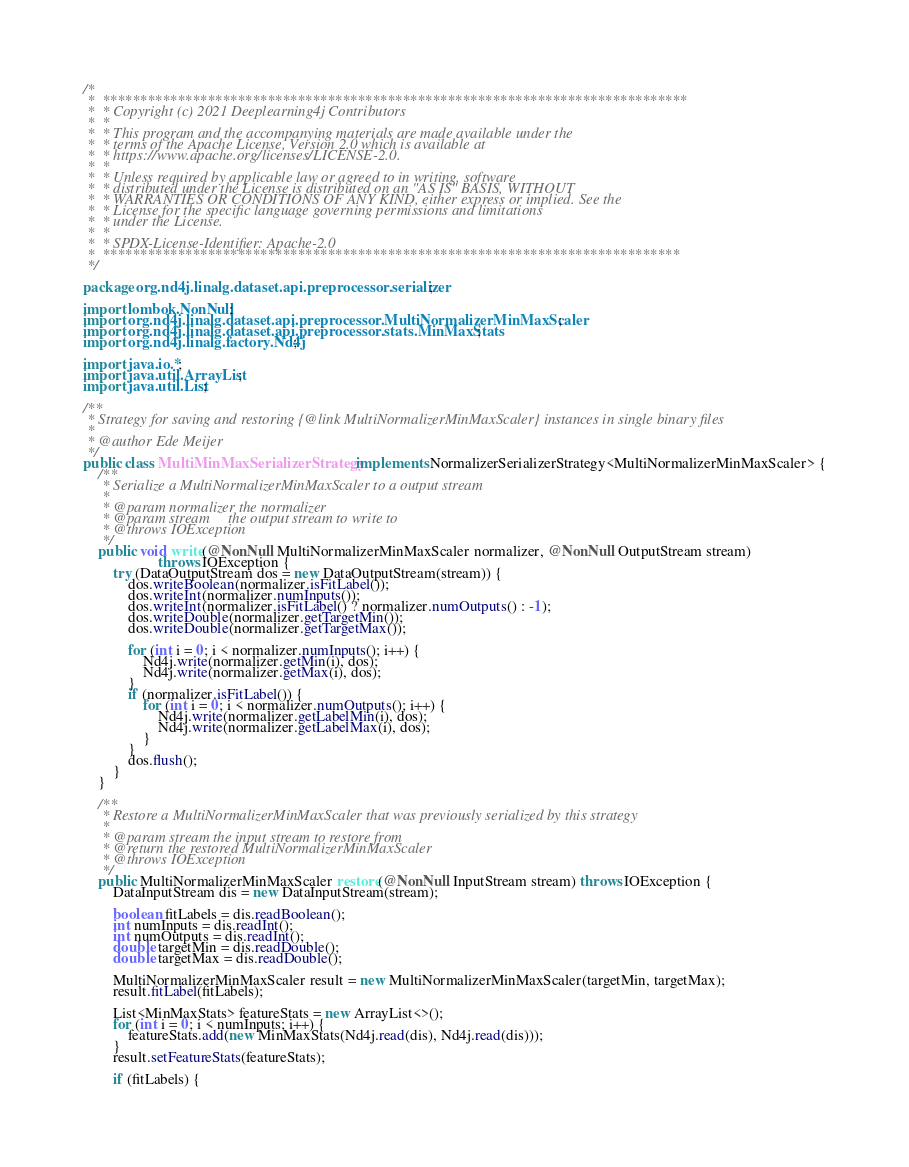<code> <loc_0><loc_0><loc_500><loc_500><_Java_>/*
 *  ******************************************************************************
 *  * Copyright (c) 2021 Deeplearning4j Contributors
 *  *
 *  * This program and the accompanying materials are made available under the
 *  * terms of the Apache License, Version 2.0 which is available at
 *  * https://www.apache.org/licenses/LICENSE-2.0.
 *  *
 *  * Unless required by applicable law or agreed to in writing, software
 *  * distributed under the License is distributed on an "AS IS" BASIS, WITHOUT
 *  * WARRANTIES OR CONDITIONS OF ANY KIND, either express or implied. See the
 *  * License for the specific language governing permissions and limitations
 *  * under the License.
 *  *
 *  * SPDX-License-Identifier: Apache-2.0
 *  *****************************************************************************
 */

package org.nd4j.linalg.dataset.api.preprocessor.serializer;

import lombok.NonNull;
import org.nd4j.linalg.dataset.api.preprocessor.MultiNormalizerMinMaxScaler;
import org.nd4j.linalg.dataset.api.preprocessor.stats.MinMaxStats;
import org.nd4j.linalg.factory.Nd4j;

import java.io.*;
import java.util.ArrayList;
import java.util.List;

/**
 * Strategy for saving and restoring {@link MultiNormalizerMinMaxScaler} instances in single binary files
 *
 * @author Ede Meijer
 */
public class MultiMinMaxSerializerStrategy implements NormalizerSerializerStrategy<MultiNormalizerMinMaxScaler> {
    /**
     * Serialize a MultiNormalizerMinMaxScaler to a output stream
     *
     * @param normalizer the normalizer
     * @param stream     the output stream to write to
     * @throws IOException
     */
    public void write(@NonNull MultiNormalizerMinMaxScaler normalizer, @NonNull OutputStream stream)
                    throws IOException {
        try (DataOutputStream dos = new DataOutputStream(stream)) {
            dos.writeBoolean(normalizer.isFitLabel());
            dos.writeInt(normalizer.numInputs());
            dos.writeInt(normalizer.isFitLabel() ? normalizer.numOutputs() : -1);
            dos.writeDouble(normalizer.getTargetMin());
            dos.writeDouble(normalizer.getTargetMax());

            for (int i = 0; i < normalizer.numInputs(); i++) {
                Nd4j.write(normalizer.getMin(i), dos);
                Nd4j.write(normalizer.getMax(i), dos);
            }
            if (normalizer.isFitLabel()) {
                for (int i = 0; i < normalizer.numOutputs(); i++) {
                    Nd4j.write(normalizer.getLabelMin(i), dos);
                    Nd4j.write(normalizer.getLabelMax(i), dos);
                }
            }
            dos.flush();
        }
    }

    /**
     * Restore a MultiNormalizerMinMaxScaler that was previously serialized by this strategy
     *
     * @param stream the input stream to restore from
     * @return the restored MultiNormalizerMinMaxScaler
     * @throws IOException
     */
    public MultiNormalizerMinMaxScaler restore(@NonNull InputStream stream) throws IOException {
        DataInputStream dis = new DataInputStream(stream);

        boolean fitLabels = dis.readBoolean();
        int numInputs = dis.readInt();
        int numOutputs = dis.readInt();
        double targetMin = dis.readDouble();
        double targetMax = dis.readDouble();

        MultiNormalizerMinMaxScaler result = new MultiNormalizerMinMaxScaler(targetMin, targetMax);
        result.fitLabel(fitLabels);

        List<MinMaxStats> featureStats = new ArrayList<>();
        for (int i = 0; i < numInputs; i++) {
            featureStats.add(new MinMaxStats(Nd4j.read(dis), Nd4j.read(dis)));
        }
        result.setFeatureStats(featureStats);

        if (fitLabels) {</code> 